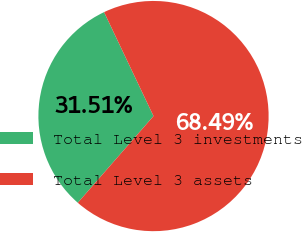Convert chart to OTSL. <chart><loc_0><loc_0><loc_500><loc_500><pie_chart><fcel>Total Level 3 investments<fcel>Total Level 3 assets<nl><fcel>31.51%<fcel>68.49%<nl></chart> 